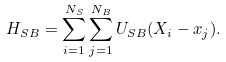<formula> <loc_0><loc_0><loc_500><loc_500>H _ { S B } = \sum _ { i = 1 } ^ { N _ { S } } \sum _ { j = 1 } ^ { N _ { B } } U _ { S B } ( X _ { i } - x _ { j } ) .</formula> 